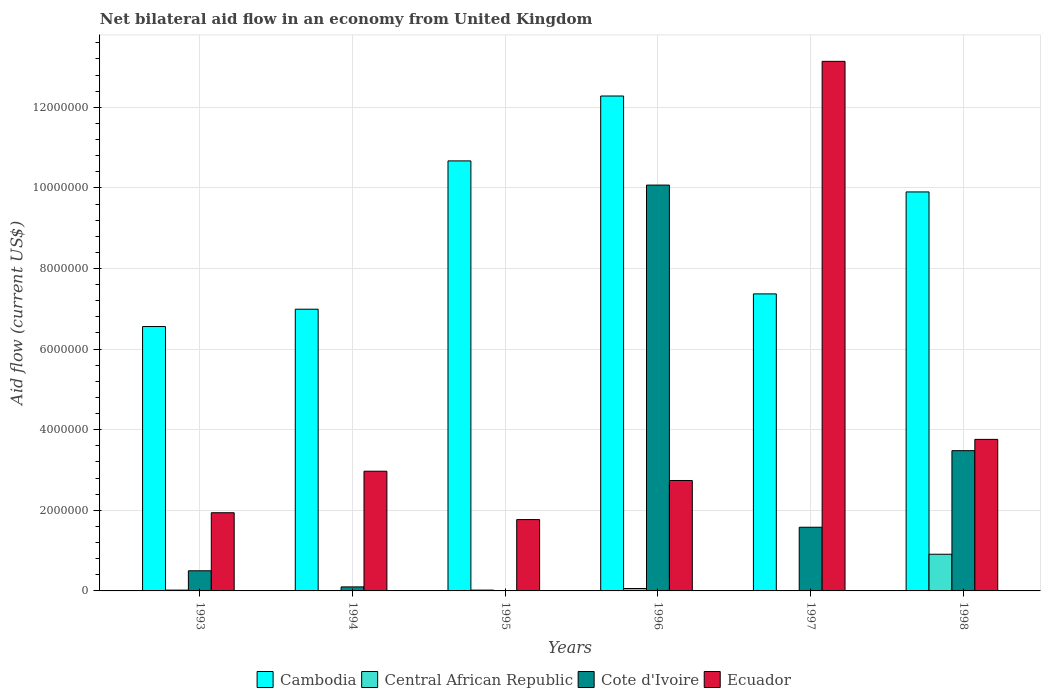How many different coloured bars are there?
Offer a terse response. 4. How many groups of bars are there?
Give a very brief answer. 6. Are the number of bars on each tick of the X-axis equal?
Your answer should be very brief. No. How many bars are there on the 2nd tick from the left?
Your answer should be compact. 4. What is the net bilateral aid flow in Cote d'Ivoire in 1996?
Make the answer very short. 1.01e+07. Across all years, what is the maximum net bilateral aid flow in Ecuador?
Your answer should be very brief. 1.31e+07. In which year was the net bilateral aid flow in Cambodia maximum?
Give a very brief answer. 1996. What is the total net bilateral aid flow in Central African Republic in the graph?
Keep it short and to the point. 1.03e+06. What is the difference between the net bilateral aid flow in Cambodia in 1993 and that in 1996?
Your answer should be very brief. -5.72e+06. What is the difference between the net bilateral aid flow in Central African Republic in 1993 and the net bilateral aid flow in Ecuador in 1996?
Keep it short and to the point. -2.72e+06. What is the average net bilateral aid flow in Cote d'Ivoire per year?
Make the answer very short. 2.62e+06. In the year 1996, what is the difference between the net bilateral aid flow in Cambodia and net bilateral aid flow in Cote d'Ivoire?
Ensure brevity in your answer.  2.21e+06. What is the ratio of the net bilateral aid flow in Ecuador in 1997 to that in 1998?
Give a very brief answer. 3.49. Is the difference between the net bilateral aid flow in Cambodia in 1996 and 1997 greater than the difference between the net bilateral aid flow in Cote d'Ivoire in 1996 and 1997?
Your answer should be compact. No. What is the difference between the highest and the second highest net bilateral aid flow in Cambodia?
Offer a terse response. 1.61e+06. What is the difference between the highest and the lowest net bilateral aid flow in Central African Republic?
Ensure brevity in your answer.  9.00e+05. Is the sum of the net bilateral aid flow in Cote d'Ivoire in 1993 and 1998 greater than the maximum net bilateral aid flow in Central African Republic across all years?
Keep it short and to the point. Yes. Is it the case that in every year, the sum of the net bilateral aid flow in Central African Republic and net bilateral aid flow in Cote d'Ivoire is greater than the net bilateral aid flow in Ecuador?
Give a very brief answer. No. How many years are there in the graph?
Offer a very short reply. 6. Does the graph contain any zero values?
Your answer should be compact. Yes. Where does the legend appear in the graph?
Your response must be concise. Bottom center. How are the legend labels stacked?
Provide a succinct answer. Horizontal. What is the title of the graph?
Make the answer very short. Net bilateral aid flow in an economy from United Kingdom. Does "High income: nonOECD" appear as one of the legend labels in the graph?
Provide a succinct answer. No. What is the label or title of the X-axis?
Keep it short and to the point. Years. What is the label or title of the Y-axis?
Ensure brevity in your answer.  Aid flow (current US$). What is the Aid flow (current US$) in Cambodia in 1993?
Provide a short and direct response. 6.56e+06. What is the Aid flow (current US$) in Central African Republic in 1993?
Your answer should be compact. 2.00e+04. What is the Aid flow (current US$) of Cote d'Ivoire in 1993?
Your answer should be compact. 5.00e+05. What is the Aid flow (current US$) in Ecuador in 1993?
Make the answer very short. 1.94e+06. What is the Aid flow (current US$) in Cambodia in 1994?
Provide a succinct answer. 6.99e+06. What is the Aid flow (current US$) in Ecuador in 1994?
Make the answer very short. 2.97e+06. What is the Aid flow (current US$) in Cambodia in 1995?
Give a very brief answer. 1.07e+07. What is the Aid flow (current US$) of Central African Republic in 1995?
Your answer should be compact. 2.00e+04. What is the Aid flow (current US$) of Cote d'Ivoire in 1995?
Provide a short and direct response. 0. What is the Aid flow (current US$) of Ecuador in 1995?
Offer a very short reply. 1.77e+06. What is the Aid flow (current US$) in Cambodia in 1996?
Your answer should be compact. 1.23e+07. What is the Aid flow (current US$) in Central African Republic in 1996?
Ensure brevity in your answer.  6.00e+04. What is the Aid flow (current US$) of Cote d'Ivoire in 1996?
Make the answer very short. 1.01e+07. What is the Aid flow (current US$) of Ecuador in 1996?
Your response must be concise. 2.74e+06. What is the Aid flow (current US$) of Cambodia in 1997?
Your response must be concise. 7.37e+06. What is the Aid flow (current US$) in Central African Republic in 1997?
Provide a short and direct response. 10000. What is the Aid flow (current US$) of Cote d'Ivoire in 1997?
Provide a succinct answer. 1.58e+06. What is the Aid flow (current US$) in Ecuador in 1997?
Keep it short and to the point. 1.31e+07. What is the Aid flow (current US$) in Cambodia in 1998?
Your answer should be compact. 9.90e+06. What is the Aid flow (current US$) in Central African Republic in 1998?
Your answer should be compact. 9.10e+05. What is the Aid flow (current US$) of Cote d'Ivoire in 1998?
Give a very brief answer. 3.48e+06. What is the Aid flow (current US$) in Ecuador in 1998?
Ensure brevity in your answer.  3.76e+06. Across all years, what is the maximum Aid flow (current US$) in Cambodia?
Give a very brief answer. 1.23e+07. Across all years, what is the maximum Aid flow (current US$) in Central African Republic?
Ensure brevity in your answer.  9.10e+05. Across all years, what is the maximum Aid flow (current US$) of Cote d'Ivoire?
Ensure brevity in your answer.  1.01e+07. Across all years, what is the maximum Aid flow (current US$) of Ecuador?
Your response must be concise. 1.31e+07. Across all years, what is the minimum Aid flow (current US$) in Cambodia?
Ensure brevity in your answer.  6.56e+06. Across all years, what is the minimum Aid flow (current US$) in Cote d'Ivoire?
Ensure brevity in your answer.  0. Across all years, what is the minimum Aid flow (current US$) of Ecuador?
Make the answer very short. 1.77e+06. What is the total Aid flow (current US$) of Cambodia in the graph?
Offer a terse response. 5.38e+07. What is the total Aid flow (current US$) in Central African Republic in the graph?
Give a very brief answer. 1.03e+06. What is the total Aid flow (current US$) in Cote d'Ivoire in the graph?
Offer a very short reply. 1.57e+07. What is the total Aid flow (current US$) in Ecuador in the graph?
Provide a short and direct response. 2.63e+07. What is the difference between the Aid flow (current US$) of Cambodia in 1993 and that in 1994?
Provide a succinct answer. -4.30e+05. What is the difference between the Aid flow (current US$) of Cote d'Ivoire in 1993 and that in 1994?
Provide a succinct answer. 4.00e+05. What is the difference between the Aid flow (current US$) of Ecuador in 1993 and that in 1994?
Keep it short and to the point. -1.03e+06. What is the difference between the Aid flow (current US$) of Cambodia in 1993 and that in 1995?
Provide a short and direct response. -4.11e+06. What is the difference between the Aid flow (current US$) in Central African Republic in 1993 and that in 1995?
Your answer should be very brief. 0. What is the difference between the Aid flow (current US$) of Ecuador in 1993 and that in 1995?
Make the answer very short. 1.70e+05. What is the difference between the Aid flow (current US$) of Cambodia in 1993 and that in 1996?
Your answer should be compact. -5.72e+06. What is the difference between the Aid flow (current US$) in Cote d'Ivoire in 1993 and that in 1996?
Your response must be concise. -9.57e+06. What is the difference between the Aid flow (current US$) in Ecuador in 1993 and that in 1996?
Make the answer very short. -8.00e+05. What is the difference between the Aid flow (current US$) of Cambodia in 1993 and that in 1997?
Your answer should be very brief. -8.10e+05. What is the difference between the Aid flow (current US$) of Central African Republic in 1993 and that in 1997?
Ensure brevity in your answer.  10000. What is the difference between the Aid flow (current US$) in Cote d'Ivoire in 1993 and that in 1997?
Ensure brevity in your answer.  -1.08e+06. What is the difference between the Aid flow (current US$) in Ecuador in 1993 and that in 1997?
Give a very brief answer. -1.12e+07. What is the difference between the Aid flow (current US$) of Cambodia in 1993 and that in 1998?
Your response must be concise. -3.34e+06. What is the difference between the Aid flow (current US$) of Central African Republic in 1993 and that in 1998?
Give a very brief answer. -8.90e+05. What is the difference between the Aid flow (current US$) of Cote d'Ivoire in 1993 and that in 1998?
Give a very brief answer. -2.98e+06. What is the difference between the Aid flow (current US$) in Ecuador in 1993 and that in 1998?
Provide a short and direct response. -1.82e+06. What is the difference between the Aid flow (current US$) in Cambodia in 1994 and that in 1995?
Offer a very short reply. -3.68e+06. What is the difference between the Aid flow (current US$) in Central African Republic in 1994 and that in 1995?
Provide a succinct answer. -10000. What is the difference between the Aid flow (current US$) of Ecuador in 1994 and that in 1995?
Keep it short and to the point. 1.20e+06. What is the difference between the Aid flow (current US$) of Cambodia in 1994 and that in 1996?
Your response must be concise. -5.29e+06. What is the difference between the Aid flow (current US$) of Central African Republic in 1994 and that in 1996?
Your response must be concise. -5.00e+04. What is the difference between the Aid flow (current US$) in Cote d'Ivoire in 1994 and that in 1996?
Your response must be concise. -9.97e+06. What is the difference between the Aid flow (current US$) in Ecuador in 1994 and that in 1996?
Offer a terse response. 2.30e+05. What is the difference between the Aid flow (current US$) in Cambodia in 1994 and that in 1997?
Provide a succinct answer. -3.80e+05. What is the difference between the Aid flow (current US$) in Central African Republic in 1994 and that in 1997?
Your answer should be very brief. 0. What is the difference between the Aid flow (current US$) of Cote d'Ivoire in 1994 and that in 1997?
Provide a short and direct response. -1.48e+06. What is the difference between the Aid flow (current US$) in Ecuador in 1994 and that in 1997?
Your answer should be compact. -1.02e+07. What is the difference between the Aid flow (current US$) in Cambodia in 1994 and that in 1998?
Your answer should be very brief. -2.91e+06. What is the difference between the Aid flow (current US$) in Central African Republic in 1994 and that in 1998?
Offer a terse response. -9.00e+05. What is the difference between the Aid flow (current US$) of Cote d'Ivoire in 1994 and that in 1998?
Your response must be concise. -3.38e+06. What is the difference between the Aid flow (current US$) of Ecuador in 1994 and that in 1998?
Ensure brevity in your answer.  -7.90e+05. What is the difference between the Aid flow (current US$) of Cambodia in 1995 and that in 1996?
Make the answer very short. -1.61e+06. What is the difference between the Aid flow (current US$) of Ecuador in 1995 and that in 1996?
Provide a short and direct response. -9.70e+05. What is the difference between the Aid flow (current US$) of Cambodia in 1995 and that in 1997?
Provide a short and direct response. 3.30e+06. What is the difference between the Aid flow (current US$) in Central African Republic in 1995 and that in 1997?
Your response must be concise. 10000. What is the difference between the Aid flow (current US$) in Ecuador in 1995 and that in 1997?
Your answer should be very brief. -1.14e+07. What is the difference between the Aid flow (current US$) in Cambodia in 1995 and that in 1998?
Provide a succinct answer. 7.70e+05. What is the difference between the Aid flow (current US$) of Central African Republic in 1995 and that in 1998?
Offer a terse response. -8.90e+05. What is the difference between the Aid flow (current US$) in Ecuador in 1995 and that in 1998?
Make the answer very short. -1.99e+06. What is the difference between the Aid flow (current US$) of Cambodia in 1996 and that in 1997?
Provide a succinct answer. 4.91e+06. What is the difference between the Aid flow (current US$) in Cote d'Ivoire in 1996 and that in 1997?
Your response must be concise. 8.49e+06. What is the difference between the Aid flow (current US$) of Ecuador in 1996 and that in 1997?
Give a very brief answer. -1.04e+07. What is the difference between the Aid flow (current US$) in Cambodia in 1996 and that in 1998?
Ensure brevity in your answer.  2.38e+06. What is the difference between the Aid flow (current US$) of Central African Republic in 1996 and that in 1998?
Offer a very short reply. -8.50e+05. What is the difference between the Aid flow (current US$) in Cote d'Ivoire in 1996 and that in 1998?
Offer a terse response. 6.59e+06. What is the difference between the Aid flow (current US$) in Ecuador in 1996 and that in 1998?
Offer a very short reply. -1.02e+06. What is the difference between the Aid flow (current US$) in Cambodia in 1997 and that in 1998?
Keep it short and to the point. -2.53e+06. What is the difference between the Aid flow (current US$) of Central African Republic in 1997 and that in 1998?
Provide a succinct answer. -9.00e+05. What is the difference between the Aid flow (current US$) of Cote d'Ivoire in 1997 and that in 1998?
Your response must be concise. -1.90e+06. What is the difference between the Aid flow (current US$) of Ecuador in 1997 and that in 1998?
Make the answer very short. 9.38e+06. What is the difference between the Aid flow (current US$) of Cambodia in 1993 and the Aid flow (current US$) of Central African Republic in 1994?
Your response must be concise. 6.55e+06. What is the difference between the Aid flow (current US$) of Cambodia in 1993 and the Aid flow (current US$) of Cote d'Ivoire in 1994?
Offer a very short reply. 6.46e+06. What is the difference between the Aid flow (current US$) of Cambodia in 1993 and the Aid flow (current US$) of Ecuador in 1994?
Ensure brevity in your answer.  3.59e+06. What is the difference between the Aid flow (current US$) of Central African Republic in 1993 and the Aid flow (current US$) of Cote d'Ivoire in 1994?
Your response must be concise. -8.00e+04. What is the difference between the Aid flow (current US$) of Central African Republic in 1993 and the Aid flow (current US$) of Ecuador in 1994?
Keep it short and to the point. -2.95e+06. What is the difference between the Aid flow (current US$) in Cote d'Ivoire in 1993 and the Aid flow (current US$) in Ecuador in 1994?
Your answer should be compact. -2.47e+06. What is the difference between the Aid flow (current US$) in Cambodia in 1993 and the Aid flow (current US$) in Central African Republic in 1995?
Your response must be concise. 6.54e+06. What is the difference between the Aid flow (current US$) in Cambodia in 1993 and the Aid flow (current US$) in Ecuador in 1995?
Ensure brevity in your answer.  4.79e+06. What is the difference between the Aid flow (current US$) in Central African Republic in 1993 and the Aid flow (current US$) in Ecuador in 1995?
Offer a terse response. -1.75e+06. What is the difference between the Aid flow (current US$) of Cote d'Ivoire in 1993 and the Aid flow (current US$) of Ecuador in 1995?
Your response must be concise. -1.27e+06. What is the difference between the Aid flow (current US$) of Cambodia in 1993 and the Aid flow (current US$) of Central African Republic in 1996?
Your response must be concise. 6.50e+06. What is the difference between the Aid flow (current US$) of Cambodia in 1993 and the Aid flow (current US$) of Cote d'Ivoire in 1996?
Give a very brief answer. -3.51e+06. What is the difference between the Aid flow (current US$) of Cambodia in 1993 and the Aid flow (current US$) of Ecuador in 1996?
Keep it short and to the point. 3.82e+06. What is the difference between the Aid flow (current US$) of Central African Republic in 1993 and the Aid flow (current US$) of Cote d'Ivoire in 1996?
Ensure brevity in your answer.  -1.00e+07. What is the difference between the Aid flow (current US$) of Central African Republic in 1993 and the Aid flow (current US$) of Ecuador in 1996?
Provide a short and direct response. -2.72e+06. What is the difference between the Aid flow (current US$) in Cote d'Ivoire in 1993 and the Aid flow (current US$) in Ecuador in 1996?
Keep it short and to the point. -2.24e+06. What is the difference between the Aid flow (current US$) of Cambodia in 1993 and the Aid flow (current US$) of Central African Republic in 1997?
Your response must be concise. 6.55e+06. What is the difference between the Aid flow (current US$) of Cambodia in 1993 and the Aid flow (current US$) of Cote d'Ivoire in 1997?
Provide a succinct answer. 4.98e+06. What is the difference between the Aid flow (current US$) of Cambodia in 1993 and the Aid flow (current US$) of Ecuador in 1997?
Your response must be concise. -6.58e+06. What is the difference between the Aid flow (current US$) in Central African Republic in 1993 and the Aid flow (current US$) in Cote d'Ivoire in 1997?
Make the answer very short. -1.56e+06. What is the difference between the Aid flow (current US$) of Central African Republic in 1993 and the Aid flow (current US$) of Ecuador in 1997?
Make the answer very short. -1.31e+07. What is the difference between the Aid flow (current US$) of Cote d'Ivoire in 1993 and the Aid flow (current US$) of Ecuador in 1997?
Your answer should be compact. -1.26e+07. What is the difference between the Aid flow (current US$) of Cambodia in 1993 and the Aid flow (current US$) of Central African Republic in 1998?
Provide a succinct answer. 5.65e+06. What is the difference between the Aid flow (current US$) of Cambodia in 1993 and the Aid flow (current US$) of Cote d'Ivoire in 1998?
Give a very brief answer. 3.08e+06. What is the difference between the Aid flow (current US$) of Cambodia in 1993 and the Aid flow (current US$) of Ecuador in 1998?
Make the answer very short. 2.80e+06. What is the difference between the Aid flow (current US$) in Central African Republic in 1993 and the Aid flow (current US$) in Cote d'Ivoire in 1998?
Ensure brevity in your answer.  -3.46e+06. What is the difference between the Aid flow (current US$) in Central African Republic in 1993 and the Aid flow (current US$) in Ecuador in 1998?
Ensure brevity in your answer.  -3.74e+06. What is the difference between the Aid flow (current US$) of Cote d'Ivoire in 1993 and the Aid flow (current US$) of Ecuador in 1998?
Provide a short and direct response. -3.26e+06. What is the difference between the Aid flow (current US$) in Cambodia in 1994 and the Aid flow (current US$) in Central African Republic in 1995?
Keep it short and to the point. 6.97e+06. What is the difference between the Aid flow (current US$) in Cambodia in 1994 and the Aid flow (current US$) in Ecuador in 1995?
Offer a terse response. 5.22e+06. What is the difference between the Aid flow (current US$) in Central African Republic in 1994 and the Aid flow (current US$) in Ecuador in 1995?
Ensure brevity in your answer.  -1.76e+06. What is the difference between the Aid flow (current US$) in Cote d'Ivoire in 1994 and the Aid flow (current US$) in Ecuador in 1995?
Ensure brevity in your answer.  -1.67e+06. What is the difference between the Aid flow (current US$) in Cambodia in 1994 and the Aid flow (current US$) in Central African Republic in 1996?
Keep it short and to the point. 6.93e+06. What is the difference between the Aid flow (current US$) in Cambodia in 1994 and the Aid flow (current US$) in Cote d'Ivoire in 1996?
Your answer should be compact. -3.08e+06. What is the difference between the Aid flow (current US$) of Cambodia in 1994 and the Aid flow (current US$) of Ecuador in 1996?
Keep it short and to the point. 4.25e+06. What is the difference between the Aid flow (current US$) in Central African Republic in 1994 and the Aid flow (current US$) in Cote d'Ivoire in 1996?
Your answer should be very brief. -1.01e+07. What is the difference between the Aid flow (current US$) of Central African Republic in 1994 and the Aid flow (current US$) of Ecuador in 1996?
Provide a short and direct response. -2.73e+06. What is the difference between the Aid flow (current US$) of Cote d'Ivoire in 1994 and the Aid flow (current US$) of Ecuador in 1996?
Offer a terse response. -2.64e+06. What is the difference between the Aid flow (current US$) of Cambodia in 1994 and the Aid flow (current US$) of Central African Republic in 1997?
Ensure brevity in your answer.  6.98e+06. What is the difference between the Aid flow (current US$) in Cambodia in 1994 and the Aid flow (current US$) in Cote d'Ivoire in 1997?
Keep it short and to the point. 5.41e+06. What is the difference between the Aid flow (current US$) in Cambodia in 1994 and the Aid flow (current US$) in Ecuador in 1997?
Make the answer very short. -6.15e+06. What is the difference between the Aid flow (current US$) in Central African Republic in 1994 and the Aid flow (current US$) in Cote d'Ivoire in 1997?
Offer a terse response. -1.57e+06. What is the difference between the Aid flow (current US$) of Central African Republic in 1994 and the Aid flow (current US$) of Ecuador in 1997?
Offer a terse response. -1.31e+07. What is the difference between the Aid flow (current US$) of Cote d'Ivoire in 1994 and the Aid flow (current US$) of Ecuador in 1997?
Your answer should be very brief. -1.30e+07. What is the difference between the Aid flow (current US$) of Cambodia in 1994 and the Aid flow (current US$) of Central African Republic in 1998?
Offer a very short reply. 6.08e+06. What is the difference between the Aid flow (current US$) of Cambodia in 1994 and the Aid flow (current US$) of Cote d'Ivoire in 1998?
Offer a terse response. 3.51e+06. What is the difference between the Aid flow (current US$) of Cambodia in 1994 and the Aid flow (current US$) of Ecuador in 1998?
Offer a terse response. 3.23e+06. What is the difference between the Aid flow (current US$) in Central African Republic in 1994 and the Aid flow (current US$) in Cote d'Ivoire in 1998?
Offer a terse response. -3.47e+06. What is the difference between the Aid flow (current US$) of Central African Republic in 1994 and the Aid flow (current US$) of Ecuador in 1998?
Provide a succinct answer. -3.75e+06. What is the difference between the Aid flow (current US$) in Cote d'Ivoire in 1994 and the Aid flow (current US$) in Ecuador in 1998?
Your response must be concise. -3.66e+06. What is the difference between the Aid flow (current US$) of Cambodia in 1995 and the Aid flow (current US$) of Central African Republic in 1996?
Offer a very short reply. 1.06e+07. What is the difference between the Aid flow (current US$) in Cambodia in 1995 and the Aid flow (current US$) in Ecuador in 1996?
Make the answer very short. 7.93e+06. What is the difference between the Aid flow (current US$) of Central African Republic in 1995 and the Aid flow (current US$) of Cote d'Ivoire in 1996?
Provide a short and direct response. -1.00e+07. What is the difference between the Aid flow (current US$) in Central African Republic in 1995 and the Aid flow (current US$) in Ecuador in 1996?
Provide a succinct answer. -2.72e+06. What is the difference between the Aid flow (current US$) in Cambodia in 1995 and the Aid flow (current US$) in Central African Republic in 1997?
Your answer should be very brief. 1.07e+07. What is the difference between the Aid flow (current US$) in Cambodia in 1995 and the Aid flow (current US$) in Cote d'Ivoire in 1997?
Offer a terse response. 9.09e+06. What is the difference between the Aid flow (current US$) in Cambodia in 1995 and the Aid flow (current US$) in Ecuador in 1997?
Keep it short and to the point. -2.47e+06. What is the difference between the Aid flow (current US$) in Central African Republic in 1995 and the Aid flow (current US$) in Cote d'Ivoire in 1997?
Your answer should be very brief. -1.56e+06. What is the difference between the Aid flow (current US$) of Central African Republic in 1995 and the Aid flow (current US$) of Ecuador in 1997?
Offer a very short reply. -1.31e+07. What is the difference between the Aid flow (current US$) of Cambodia in 1995 and the Aid flow (current US$) of Central African Republic in 1998?
Offer a very short reply. 9.76e+06. What is the difference between the Aid flow (current US$) in Cambodia in 1995 and the Aid flow (current US$) in Cote d'Ivoire in 1998?
Your answer should be compact. 7.19e+06. What is the difference between the Aid flow (current US$) in Cambodia in 1995 and the Aid flow (current US$) in Ecuador in 1998?
Give a very brief answer. 6.91e+06. What is the difference between the Aid flow (current US$) of Central African Republic in 1995 and the Aid flow (current US$) of Cote d'Ivoire in 1998?
Give a very brief answer. -3.46e+06. What is the difference between the Aid flow (current US$) of Central African Republic in 1995 and the Aid flow (current US$) of Ecuador in 1998?
Make the answer very short. -3.74e+06. What is the difference between the Aid flow (current US$) of Cambodia in 1996 and the Aid flow (current US$) of Central African Republic in 1997?
Your response must be concise. 1.23e+07. What is the difference between the Aid flow (current US$) of Cambodia in 1996 and the Aid flow (current US$) of Cote d'Ivoire in 1997?
Your answer should be very brief. 1.07e+07. What is the difference between the Aid flow (current US$) of Cambodia in 1996 and the Aid flow (current US$) of Ecuador in 1997?
Make the answer very short. -8.60e+05. What is the difference between the Aid flow (current US$) of Central African Republic in 1996 and the Aid flow (current US$) of Cote d'Ivoire in 1997?
Make the answer very short. -1.52e+06. What is the difference between the Aid flow (current US$) of Central African Republic in 1996 and the Aid flow (current US$) of Ecuador in 1997?
Offer a very short reply. -1.31e+07. What is the difference between the Aid flow (current US$) of Cote d'Ivoire in 1996 and the Aid flow (current US$) of Ecuador in 1997?
Make the answer very short. -3.07e+06. What is the difference between the Aid flow (current US$) in Cambodia in 1996 and the Aid flow (current US$) in Central African Republic in 1998?
Your response must be concise. 1.14e+07. What is the difference between the Aid flow (current US$) of Cambodia in 1996 and the Aid flow (current US$) of Cote d'Ivoire in 1998?
Your response must be concise. 8.80e+06. What is the difference between the Aid flow (current US$) of Cambodia in 1996 and the Aid flow (current US$) of Ecuador in 1998?
Your response must be concise. 8.52e+06. What is the difference between the Aid flow (current US$) in Central African Republic in 1996 and the Aid flow (current US$) in Cote d'Ivoire in 1998?
Make the answer very short. -3.42e+06. What is the difference between the Aid flow (current US$) of Central African Republic in 1996 and the Aid flow (current US$) of Ecuador in 1998?
Your answer should be very brief. -3.70e+06. What is the difference between the Aid flow (current US$) of Cote d'Ivoire in 1996 and the Aid flow (current US$) of Ecuador in 1998?
Your answer should be very brief. 6.31e+06. What is the difference between the Aid flow (current US$) in Cambodia in 1997 and the Aid flow (current US$) in Central African Republic in 1998?
Offer a very short reply. 6.46e+06. What is the difference between the Aid flow (current US$) of Cambodia in 1997 and the Aid flow (current US$) of Cote d'Ivoire in 1998?
Keep it short and to the point. 3.89e+06. What is the difference between the Aid flow (current US$) of Cambodia in 1997 and the Aid flow (current US$) of Ecuador in 1998?
Provide a short and direct response. 3.61e+06. What is the difference between the Aid flow (current US$) of Central African Republic in 1997 and the Aid flow (current US$) of Cote d'Ivoire in 1998?
Provide a succinct answer. -3.47e+06. What is the difference between the Aid flow (current US$) in Central African Republic in 1997 and the Aid flow (current US$) in Ecuador in 1998?
Offer a very short reply. -3.75e+06. What is the difference between the Aid flow (current US$) of Cote d'Ivoire in 1997 and the Aid flow (current US$) of Ecuador in 1998?
Keep it short and to the point. -2.18e+06. What is the average Aid flow (current US$) in Cambodia per year?
Offer a very short reply. 8.96e+06. What is the average Aid flow (current US$) in Central African Republic per year?
Provide a short and direct response. 1.72e+05. What is the average Aid flow (current US$) in Cote d'Ivoire per year?
Offer a very short reply. 2.62e+06. What is the average Aid flow (current US$) in Ecuador per year?
Your answer should be very brief. 4.39e+06. In the year 1993, what is the difference between the Aid flow (current US$) in Cambodia and Aid flow (current US$) in Central African Republic?
Your response must be concise. 6.54e+06. In the year 1993, what is the difference between the Aid flow (current US$) of Cambodia and Aid flow (current US$) of Cote d'Ivoire?
Your answer should be compact. 6.06e+06. In the year 1993, what is the difference between the Aid flow (current US$) of Cambodia and Aid flow (current US$) of Ecuador?
Keep it short and to the point. 4.62e+06. In the year 1993, what is the difference between the Aid flow (current US$) in Central African Republic and Aid flow (current US$) in Cote d'Ivoire?
Make the answer very short. -4.80e+05. In the year 1993, what is the difference between the Aid flow (current US$) in Central African Republic and Aid flow (current US$) in Ecuador?
Offer a very short reply. -1.92e+06. In the year 1993, what is the difference between the Aid flow (current US$) in Cote d'Ivoire and Aid flow (current US$) in Ecuador?
Your answer should be compact. -1.44e+06. In the year 1994, what is the difference between the Aid flow (current US$) in Cambodia and Aid flow (current US$) in Central African Republic?
Offer a terse response. 6.98e+06. In the year 1994, what is the difference between the Aid flow (current US$) of Cambodia and Aid flow (current US$) of Cote d'Ivoire?
Keep it short and to the point. 6.89e+06. In the year 1994, what is the difference between the Aid flow (current US$) in Cambodia and Aid flow (current US$) in Ecuador?
Your response must be concise. 4.02e+06. In the year 1994, what is the difference between the Aid flow (current US$) in Central African Republic and Aid flow (current US$) in Ecuador?
Your answer should be compact. -2.96e+06. In the year 1994, what is the difference between the Aid flow (current US$) of Cote d'Ivoire and Aid flow (current US$) of Ecuador?
Keep it short and to the point. -2.87e+06. In the year 1995, what is the difference between the Aid flow (current US$) of Cambodia and Aid flow (current US$) of Central African Republic?
Give a very brief answer. 1.06e+07. In the year 1995, what is the difference between the Aid flow (current US$) in Cambodia and Aid flow (current US$) in Ecuador?
Provide a succinct answer. 8.90e+06. In the year 1995, what is the difference between the Aid flow (current US$) in Central African Republic and Aid flow (current US$) in Ecuador?
Your answer should be very brief. -1.75e+06. In the year 1996, what is the difference between the Aid flow (current US$) in Cambodia and Aid flow (current US$) in Central African Republic?
Provide a short and direct response. 1.22e+07. In the year 1996, what is the difference between the Aid flow (current US$) of Cambodia and Aid flow (current US$) of Cote d'Ivoire?
Offer a very short reply. 2.21e+06. In the year 1996, what is the difference between the Aid flow (current US$) of Cambodia and Aid flow (current US$) of Ecuador?
Ensure brevity in your answer.  9.54e+06. In the year 1996, what is the difference between the Aid flow (current US$) of Central African Republic and Aid flow (current US$) of Cote d'Ivoire?
Provide a succinct answer. -1.00e+07. In the year 1996, what is the difference between the Aid flow (current US$) in Central African Republic and Aid flow (current US$) in Ecuador?
Provide a short and direct response. -2.68e+06. In the year 1996, what is the difference between the Aid flow (current US$) of Cote d'Ivoire and Aid flow (current US$) of Ecuador?
Keep it short and to the point. 7.33e+06. In the year 1997, what is the difference between the Aid flow (current US$) of Cambodia and Aid flow (current US$) of Central African Republic?
Offer a very short reply. 7.36e+06. In the year 1997, what is the difference between the Aid flow (current US$) of Cambodia and Aid flow (current US$) of Cote d'Ivoire?
Give a very brief answer. 5.79e+06. In the year 1997, what is the difference between the Aid flow (current US$) of Cambodia and Aid flow (current US$) of Ecuador?
Give a very brief answer. -5.77e+06. In the year 1997, what is the difference between the Aid flow (current US$) in Central African Republic and Aid flow (current US$) in Cote d'Ivoire?
Offer a very short reply. -1.57e+06. In the year 1997, what is the difference between the Aid flow (current US$) in Central African Republic and Aid flow (current US$) in Ecuador?
Keep it short and to the point. -1.31e+07. In the year 1997, what is the difference between the Aid flow (current US$) of Cote d'Ivoire and Aid flow (current US$) of Ecuador?
Make the answer very short. -1.16e+07. In the year 1998, what is the difference between the Aid flow (current US$) of Cambodia and Aid flow (current US$) of Central African Republic?
Ensure brevity in your answer.  8.99e+06. In the year 1998, what is the difference between the Aid flow (current US$) in Cambodia and Aid flow (current US$) in Cote d'Ivoire?
Provide a short and direct response. 6.42e+06. In the year 1998, what is the difference between the Aid flow (current US$) in Cambodia and Aid flow (current US$) in Ecuador?
Your answer should be compact. 6.14e+06. In the year 1998, what is the difference between the Aid flow (current US$) in Central African Republic and Aid flow (current US$) in Cote d'Ivoire?
Make the answer very short. -2.57e+06. In the year 1998, what is the difference between the Aid flow (current US$) of Central African Republic and Aid flow (current US$) of Ecuador?
Ensure brevity in your answer.  -2.85e+06. In the year 1998, what is the difference between the Aid flow (current US$) of Cote d'Ivoire and Aid flow (current US$) of Ecuador?
Offer a terse response. -2.80e+05. What is the ratio of the Aid flow (current US$) of Cambodia in 1993 to that in 1994?
Your answer should be compact. 0.94. What is the ratio of the Aid flow (current US$) in Central African Republic in 1993 to that in 1994?
Offer a very short reply. 2. What is the ratio of the Aid flow (current US$) in Cote d'Ivoire in 1993 to that in 1994?
Your response must be concise. 5. What is the ratio of the Aid flow (current US$) in Ecuador in 1993 to that in 1994?
Make the answer very short. 0.65. What is the ratio of the Aid flow (current US$) of Cambodia in 1993 to that in 1995?
Offer a very short reply. 0.61. What is the ratio of the Aid flow (current US$) in Ecuador in 1993 to that in 1995?
Keep it short and to the point. 1.1. What is the ratio of the Aid flow (current US$) of Cambodia in 1993 to that in 1996?
Give a very brief answer. 0.53. What is the ratio of the Aid flow (current US$) in Central African Republic in 1993 to that in 1996?
Offer a terse response. 0.33. What is the ratio of the Aid flow (current US$) of Cote d'Ivoire in 1993 to that in 1996?
Offer a very short reply. 0.05. What is the ratio of the Aid flow (current US$) of Ecuador in 1993 to that in 1996?
Provide a succinct answer. 0.71. What is the ratio of the Aid flow (current US$) in Cambodia in 1993 to that in 1997?
Make the answer very short. 0.89. What is the ratio of the Aid flow (current US$) in Cote d'Ivoire in 1993 to that in 1997?
Your answer should be very brief. 0.32. What is the ratio of the Aid flow (current US$) in Ecuador in 1993 to that in 1997?
Keep it short and to the point. 0.15. What is the ratio of the Aid flow (current US$) of Cambodia in 1993 to that in 1998?
Ensure brevity in your answer.  0.66. What is the ratio of the Aid flow (current US$) in Central African Republic in 1993 to that in 1998?
Your response must be concise. 0.02. What is the ratio of the Aid flow (current US$) of Cote d'Ivoire in 1993 to that in 1998?
Offer a terse response. 0.14. What is the ratio of the Aid flow (current US$) of Ecuador in 1993 to that in 1998?
Offer a very short reply. 0.52. What is the ratio of the Aid flow (current US$) in Cambodia in 1994 to that in 1995?
Give a very brief answer. 0.66. What is the ratio of the Aid flow (current US$) in Central African Republic in 1994 to that in 1995?
Provide a short and direct response. 0.5. What is the ratio of the Aid flow (current US$) in Ecuador in 1994 to that in 1995?
Keep it short and to the point. 1.68. What is the ratio of the Aid flow (current US$) of Cambodia in 1994 to that in 1996?
Provide a short and direct response. 0.57. What is the ratio of the Aid flow (current US$) in Central African Republic in 1994 to that in 1996?
Keep it short and to the point. 0.17. What is the ratio of the Aid flow (current US$) of Cote d'Ivoire in 1994 to that in 1996?
Give a very brief answer. 0.01. What is the ratio of the Aid flow (current US$) in Ecuador in 1994 to that in 1996?
Keep it short and to the point. 1.08. What is the ratio of the Aid flow (current US$) of Cambodia in 1994 to that in 1997?
Your answer should be compact. 0.95. What is the ratio of the Aid flow (current US$) in Cote d'Ivoire in 1994 to that in 1997?
Offer a terse response. 0.06. What is the ratio of the Aid flow (current US$) in Ecuador in 1994 to that in 1997?
Give a very brief answer. 0.23. What is the ratio of the Aid flow (current US$) in Cambodia in 1994 to that in 1998?
Your response must be concise. 0.71. What is the ratio of the Aid flow (current US$) in Central African Republic in 1994 to that in 1998?
Your answer should be very brief. 0.01. What is the ratio of the Aid flow (current US$) in Cote d'Ivoire in 1994 to that in 1998?
Keep it short and to the point. 0.03. What is the ratio of the Aid flow (current US$) of Ecuador in 1994 to that in 1998?
Keep it short and to the point. 0.79. What is the ratio of the Aid flow (current US$) in Cambodia in 1995 to that in 1996?
Your response must be concise. 0.87. What is the ratio of the Aid flow (current US$) in Central African Republic in 1995 to that in 1996?
Offer a terse response. 0.33. What is the ratio of the Aid flow (current US$) in Ecuador in 1995 to that in 1996?
Make the answer very short. 0.65. What is the ratio of the Aid flow (current US$) in Cambodia in 1995 to that in 1997?
Offer a very short reply. 1.45. What is the ratio of the Aid flow (current US$) of Ecuador in 1995 to that in 1997?
Give a very brief answer. 0.13. What is the ratio of the Aid flow (current US$) of Cambodia in 1995 to that in 1998?
Ensure brevity in your answer.  1.08. What is the ratio of the Aid flow (current US$) of Central African Republic in 1995 to that in 1998?
Give a very brief answer. 0.02. What is the ratio of the Aid flow (current US$) of Ecuador in 1995 to that in 1998?
Give a very brief answer. 0.47. What is the ratio of the Aid flow (current US$) of Cambodia in 1996 to that in 1997?
Your answer should be very brief. 1.67. What is the ratio of the Aid flow (current US$) in Central African Republic in 1996 to that in 1997?
Provide a short and direct response. 6. What is the ratio of the Aid flow (current US$) in Cote d'Ivoire in 1996 to that in 1997?
Keep it short and to the point. 6.37. What is the ratio of the Aid flow (current US$) of Ecuador in 1996 to that in 1997?
Provide a short and direct response. 0.21. What is the ratio of the Aid flow (current US$) in Cambodia in 1996 to that in 1998?
Provide a short and direct response. 1.24. What is the ratio of the Aid flow (current US$) in Central African Republic in 1996 to that in 1998?
Make the answer very short. 0.07. What is the ratio of the Aid flow (current US$) in Cote d'Ivoire in 1996 to that in 1998?
Make the answer very short. 2.89. What is the ratio of the Aid flow (current US$) in Ecuador in 1996 to that in 1998?
Your answer should be compact. 0.73. What is the ratio of the Aid flow (current US$) of Cambodia in 1997 to that in 1998?
Ensure brevity in your answer.  0.74. What is the ratio of the Aid flow (current US$) in Central African Republic in 1997 to that in 1998?
Your answer should be very brief. 0.01. What is the ratio of the Aid flow (current US$) in Cote d'Ivoire in 1997 to that in 1998?
Your answer should be compact. 0.45. What is the ratio of the Aid flow (current US$) of Ecuador in 1997 to that in 1998?
Your response must be concise. 3.49. What is the difference between the highest and the second highest Aid flow (current US$) of Cambodia?
Ensure brevity in your answer.  1.61e+06. What is the difference between the highest and the second highest Aid flow (current US$) in Central African Republic?
Offer a very short reply. 8.50e+05. What is the difference between the highest and the second highest Aid flow (current US$) in Cote d'Ivoire?
Provide a short and direct response. 6.59e+06. What is the difference between the highest and the second highest Aid flow (current US$) of Ecuador?
Your answer should be very brief. 9.38e+06. What is the difference between the highest and the lowest Aid flow (current US$) of Cambodia?
Make the answer very short. 5.72e+06. What is the difference between the highest and the lowest Aid flow (current US$) in Cote d'Ivoire?
Offer a terse response. 1.01e+07. What is the difference between the highest and the lowest Aid flow (current US$) in Ecuador?
Offer a terse response. 1.14e+07. 